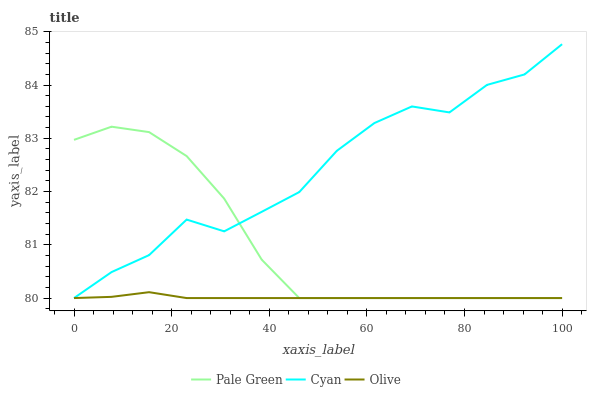Does Olive have the minimum area under the curve?
Answer yes or no. Yes. Does Cyan have the maximum area under the curve?
Answer yes or no. Yes. Does Pale Green have the minimum area under the curve?
Answer yes or no. No. Does Pale Green have the maximum area under the curve?
Answer yes or no. No. Is Olive the smoothest?
Answer yes or no. Yes. Is Cyan the roughest?
Answer yes or no. Yes. Is Pale Green the smoothest?
Answer yes or no. No. Is Pale Green the roughest?
Answer yes or no. No. Does Olive have the lowest value?
Answer yes or no. Yes. Does Cyan have the highest value?
Answer yes or no. Yes. Does Pale Green have the highest value?
Answer yes or no. No. Does Pale Green intersect Cyan?
Answer yes or no. Yes. Is Pale Green less than Cyan?
Answer yes or no. No. Is Pale Green greater than Cyan?
Answer yes or no. No. 